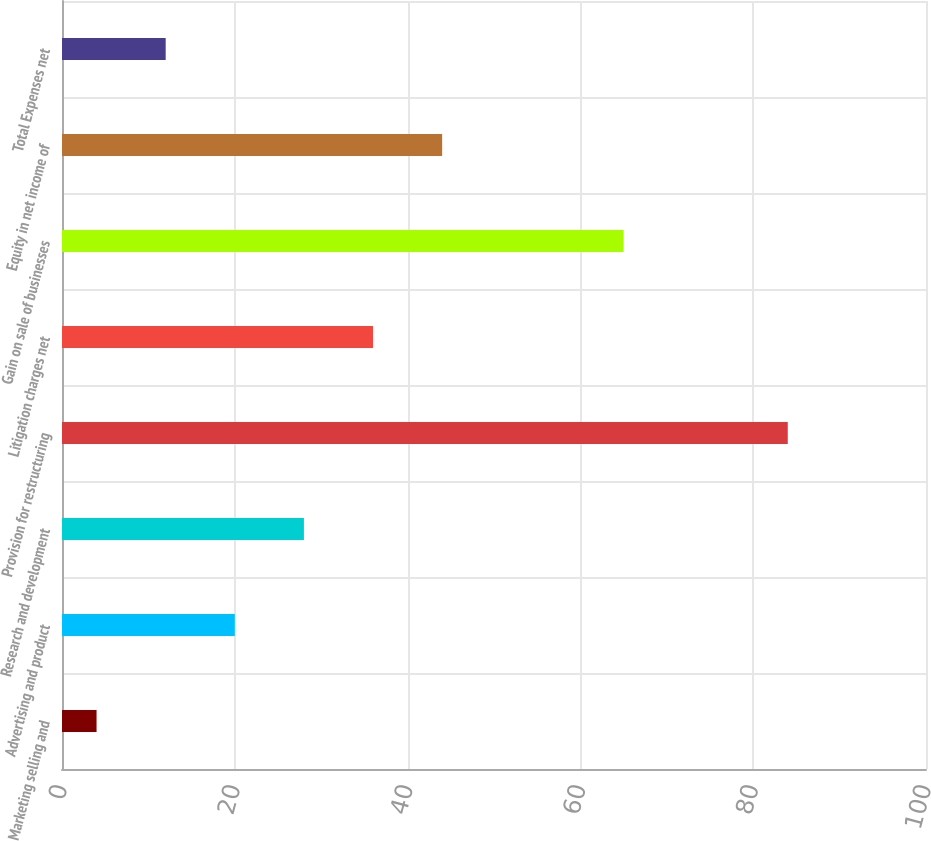Convert chart. <chart><loc_0><loc_0><loc_500><loc_500><bar_chart><fcel>Marketing selling and<fcel>Advertising and product<fcel>Research and development<fcel>Provision for restructuring<fcel>Litigation charges net<fcel>Gain on sale of businesses<fcel>Equity in net income of<fcel>Total Expenses net<nl><fcel>4<fcel>20<fcel>28<fcel>84<fcel>36<fcel>65<fcel>44<fcel>12<nl></chart> 